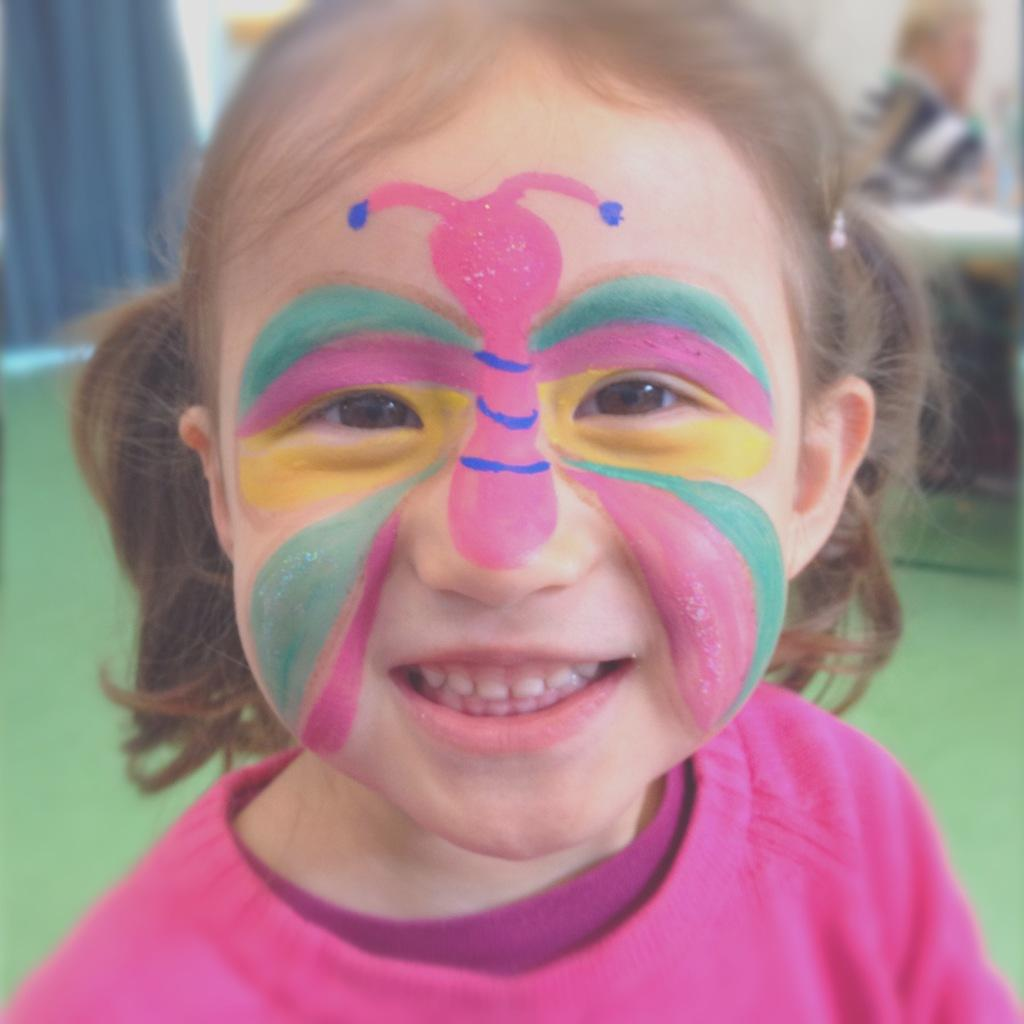What is the main subject of the image? The main subject of the image is a kid. Can you describe any specific features of the kid? Yes, the kid has a painted face. What is the rate of the calendar in the image? There is no calendar present in the image, so it is not possible to determine a rate. 